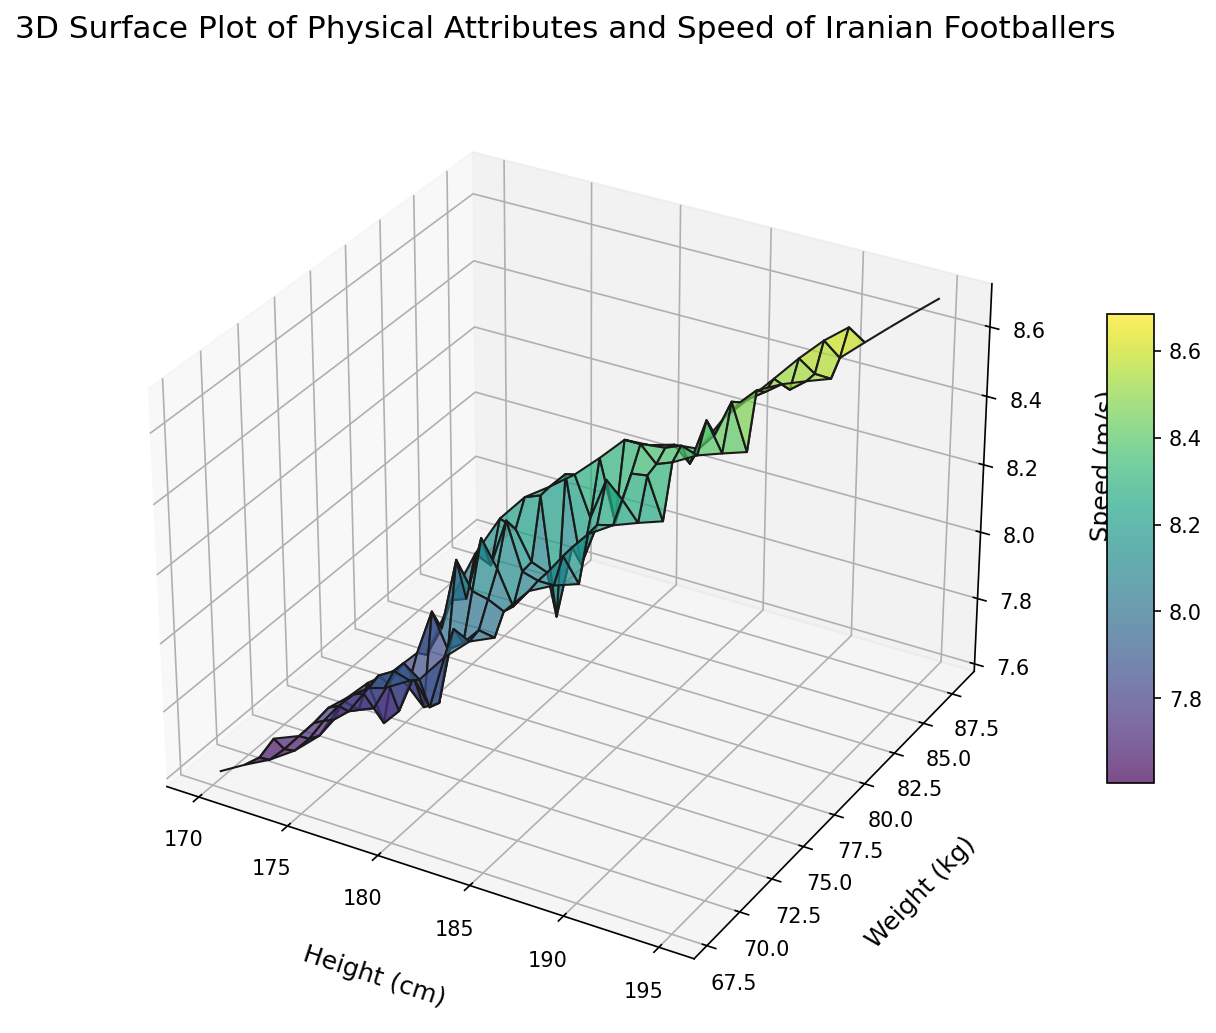What is the overall trend in speed as height increases from 170 cm to 195 cm? The 3D surface plot shows that as the height increases from 170 cm to 195 cm, the speed of the players generally increases. This upward trend is visible as the surface moves higher in the speed (z-axis) as you follow the height (x-axis) from left to right.
Answer: The trend indicates increasing speed with increasing height Is there a specific height and weight combination that corresponds to the highest speed value on the plot? The plot indicates that the highest speed value (around 8.7 m/s) is reached with a combination of height around 195 cm and weight approximately 88 kg, as visible from the peak on the 3D surface.
Answer: Height ~195 cm and Weight ~88 kg How does the speed vary between players with similar weight but different heights? For players with similar weights, such as around 75 kg, comparing different heights (e.g., 180 cm and 185 cm), the plot shows that the taller player (185 cm) tends to have a slightly higher speed. This indicates that among players of the same weight, height may contribute to higher speed.
Answer: Taller players with the same weight tend to have higher speed Which visual attributes help identify the areas of highest speed on the plot? The highest speed areas on the plot are identified by peaks on the 3D surface and the color gradient. The regions with the highest speed appear as peaks with darker shades of green to yellow in the viridis color map used.
Answer: Peaks and darker shades of green to yellow Are there any weight ranges where speed doesn't vary significantly with height? Observing the 3D surface plot, the speed doesn't vary significantly with height for the weight range around 70-72 kg. This is visible where the surface remains relatively flat along the height axis for these weight levels.
Answer: Weight range ~70-72 kg What combination of height and weight corresponds to a speed around 8.6 m/s? Based on the surface plot, the combination of height around 190-192 cm and weight approximately 85-86 kg corresponds to a speed of around 8.6 m/s. This can be seen where the surface elevation aligns with the 8.6 m/s mark.
Answer: Height ~190-192 cm and Weight ~85-86 kg Which group of players is likely to have a speed less than 8.0 m/s based on the plot? Players with heights less than 175 cm and weights less than 70 kg are likely to have speeds less than 8.0 m/s, as indicated by the lower portions of the surface plot in these ranges.
Answer: Height < 175 cm and Weight < 70 kg How does the relationship between weight and speed differ for players above and below 180 cm in height? For players above 180 cm, the relationship shows a more consistent increase in speed with increasing weight, as seen by the upward slope in the surface plot. Below 180 cm, the relationship is less clear, with speed increasing at a slower rate or remaining constant as weight increases.
Answer: Above 180 cm: speed increases with weight, Below 180 cm: slower or no significant increase in speed 